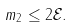Convert formula to latex. <formula><loc_0><loc_0><loc_500><loc_500>m _ { 2 } \leq 2 \mathcal { E } .</formula> 